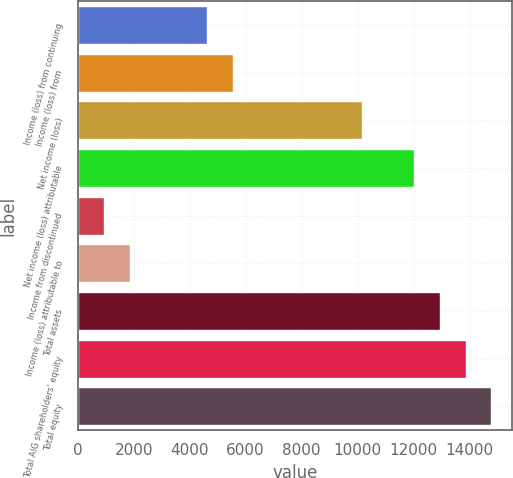Convert chart to OTSL. <chart><loc_0><loc_0><loc_500><loc_500><bar_chart><fcel>Income (loss) from continuing<fcel>Income (loss) from<fcel>Net income (loss)<fcel>Net income (loss) attributable<fcel>Income from discontinued<fcel>Income (loss) attributable to<fcel>Total assets<fcel>Total AIG shareholders' equity<fcel>Total equity<nl><fcel>4620.71<fcel>5544.37<fcel>10162.7<fcel>12010<fcel>926.07<fcel>1849.73<fcel>12933.6<fcel>13857.3<fcel>14781<nl></chart> 